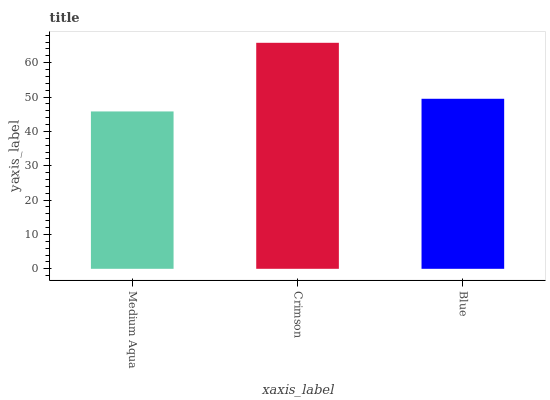Is Medium Aqua the minimum?
Answer yes or no. Yes. Is Crimson the maximum?
Answer yes or no. Yes. Is Blue the minimum?
Answer yes or no. No. Is Blue the maximum?
Answer yes or no. No. Is Crimson greater than Blue?
Answer yes or no. Yes. Is Blue less than Crimson?
Answer yes or no. Yes. Is Blue greater than Crimson?
Answer yes or no. No. Is Crimson less than Blue?
Answer yes or no. No. Is Blue the high median?
Answer yes or no. Yes. Is Blue the low median?
Answer yes or no. Yes. Is Crimson the high median?
Answer yes or no. No. Is Medium Aqua the low median?
Answer yes or no. No. 